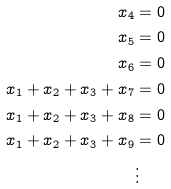<formula> <loc_0><loc_0><loc_500><loc_500>x _ { 4 } & = 0 \\ x _ { 5 } & = 0 \\ x _ { 6 } & = 0 \\ x _ { 1 } + x _ { 2 } + x _ { 3 } + x _ { 7 } & = 0 \\ x _ { 1 } + x _ { 2 } + x _ { 3 } + x _ { 8 } & = 0 \\ x _ { 1 } + x _ { 2 } + x _ { 3 } + x _ { 9 } & = 0 \\ & \vdots</formula> 